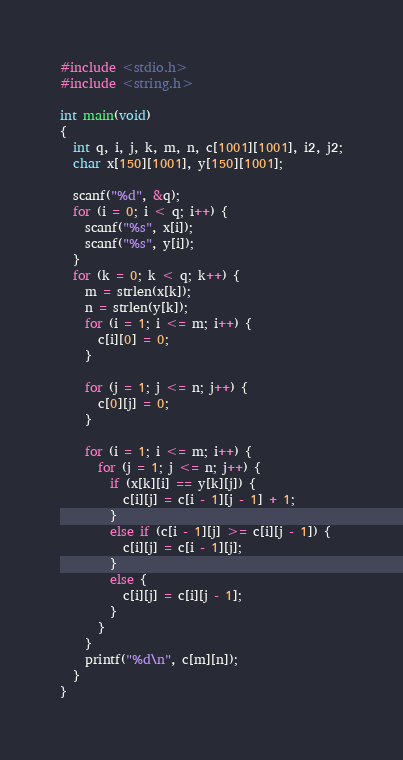<code> <loc_0><loc_0><loc_500><loc_500><_C_>#include <stdio.h>
#include <string.h>

int main(void)
{
  int q, i, j, k, m, n, c[1001][1001], i2, j2;
  char x[150][1001], y[150][1001];

  scanf("%d", &q);
  for (i = 0; i < q; i++) {
    scanf("%s", x[i]);
    scanf("%s", y[i]);
  }
  for (k = 0; k < q; k++) {
    m = strlen(x[k]);
    n = strlen(y[k]);
    for (i = 1; i <= m; i++) {
      c[i][0] = 0;
    }

    for (j = 1; j <= n; j++) {
      c[0][j] = 0;
    }

    for (i = 1; i <= m; i++) {
      for (j = 1; j <= n; j++) {
        if (x[k][i] == y[k][j]) {
          c[i][j] = c[i - 1][j - 1] + 1;
        }
        else if (c[i - 1][j] >= c[i][j - 1]) {
          c[i][j] = c[i - 1][j];
        }
        else {
          c[i][j] = c[i][j - 1];
        }
      }
    }
    printf("%d\n", c[m][n]);
  }
}</code> 